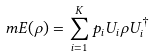<formula> <loc_0><loc_0><loc_500><loc_500>\ m E ( \rho ) = \sum _ { i = 1 } ^ { K } p _ { i } U _ { i } \rho U _ { i } ^ { \dag }</formula> 